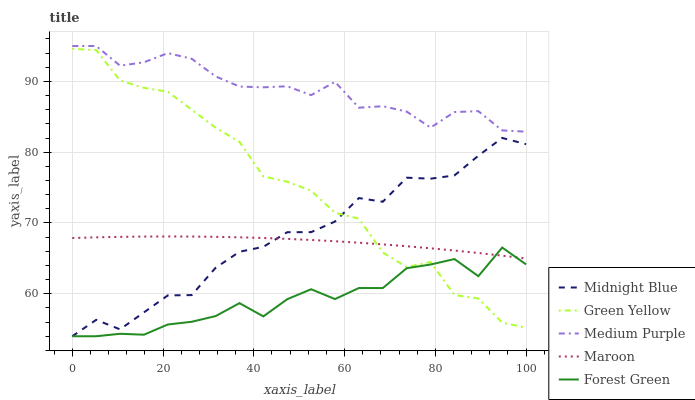Does Forest Green have the minimum area under the curve?
Answer yes or no. Yes. Does Medium Purple have the maximum area under the curve?
Answer yes or no. Yes. Does Green Yellow have the minimum area under the curve?
Answer yes or no. No. Does Green Yellow have the maximum area under the curve?
Answer yes or no. No. Is Maroon the smoothest?
Answer yes or no. Yes. Is Green Yellow the roughest?
Answer yes or no. Yes. Is Forest Green the smoothest?
Answer yes or no. No. Is Forest Green the roughest?
Answer yes or no. No. Does Forest Green have the lowest value?
Answer yes or no. Yes. Does Green Yellow have the lowest value?
Answer yes or no. No. Does Medium Purple have the highest value?
Answer yes or no. Yes. Does Green Yellow have the highest value?
Answer yes or no. No. Is Maroon less than Medium Purple?
Answer yes or no. Yes. Is Medium Purple greater than Midnight Blue?
Answer yes or no. Yes. Does Maroon intersect Forest Green?
Answer yes or no. Yes. Is Maroon less than Forest Green?
Answer yes or no. No. Is Maroon greater than Forest Green?
Answer yes or no. No. Does Maroon intersect Medium Purple?
Answer yes or no. No. 